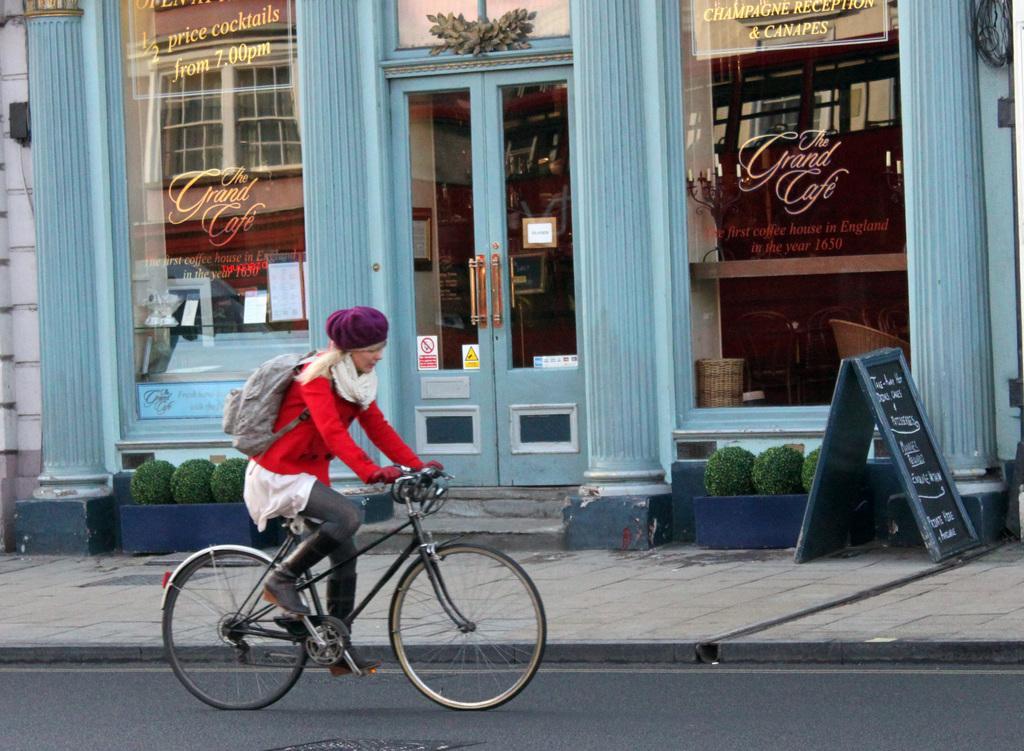In one or two sentences, can you explain what this image depicts? In the image we can see there is a person who is sitting on the bicycle and the bicycle is parked on the road and on the other side there is a building. The building is in blue colour and there is a glass window on which it's written the grand cafe. 